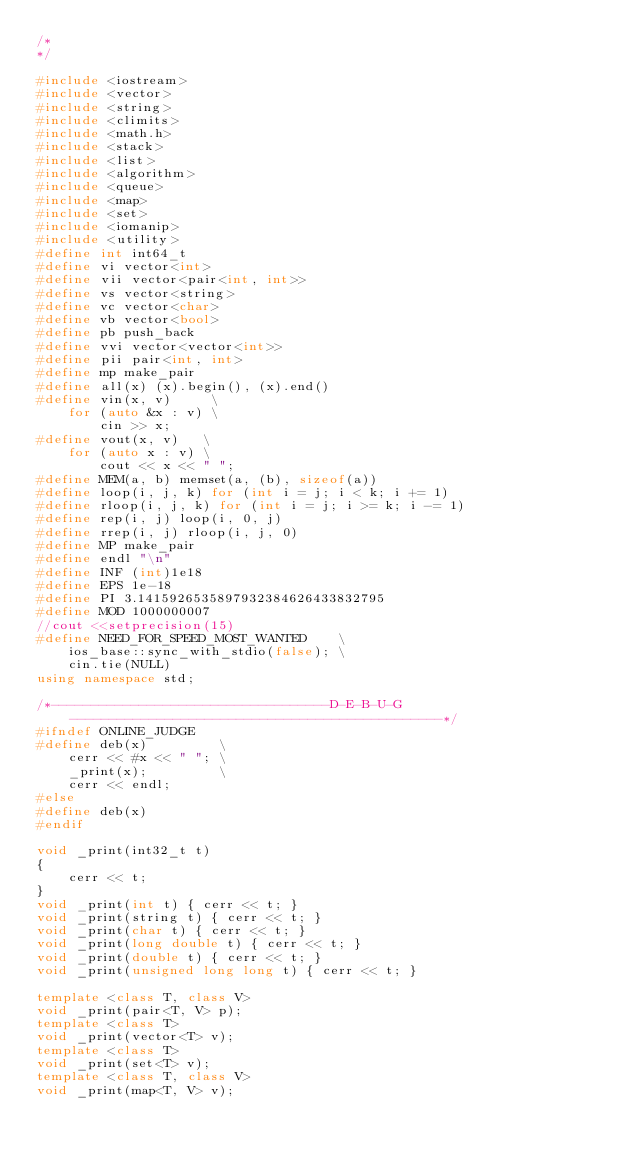Convert code to text. <code><loc_0><loc_0><loc_500><loc_500><_C++_>/*  
*/

#include <iostream>
#include <vector>
#include <string>
#include <climits>
#include <math.h>
#include <stack>
#include <list>
#include <algorithm>
#include <queue>
#include <map>
#include <set>
#include <iomanip>
#include <utility>
#define int int64_t
#define vi vector<int>
#define vii vector<pair<int, int>>
#define vs vector<string>
#define vc vector<char>
#define vb vector<bool>
#define pb push_back
#define vvi vector<vector<int>>
#define pii pair<int, int>
#define mp make_pair
#define all(x) (x).begin(), (x).end()
#define vin(x, v)     \
    for (auto &x : v) \
        cin >> x;
#define vout(x, v)   \
    for (auto x : v) \
        cout << x << " ";
#define MEM(a, b) memset(a, (b), sizeof(a))
#define loop(i, j, k) for (int i = j; i < k; i += 1)
#define rloop(i, j, k) for (int i = j; i >= k; i -= 1)
#define rep(i, j) loop(i, 0, j)
#define rrep(i, j) rloop(i, j, 0)
#define MP make_pair
#define endl "\n"
#define INF (int)1e18
#define EPS 1e-18
#define PI 3.1415926535897932384626433832795
#define MOD 1000000007
//cout <<setprecision(15)
#define NEED_FOR_SPEED_MOST_WANTED    \
    ios_base::sync_with_stdio(false); \
    cin.tie(NULL)
using namespace std;

/*-----------------------------------D-E-B-U-G-----------------------------------------------*/
#ifndef ONLINE_JUDGE
#define deb(x)         \
    cerr << #x << " "; \
    _print(x);         \
    cerr << endl;
#else
#define deb(x)
#endif

void _print(int32_t t)
{
    cerr << t;
}
void _print(int t) { cerr << t; }
void _print(string t) { cerr << t; }
void _print(char t) { cerr << t; }
void _print(long double t) { cerr << t; }
void _print(double t) { cerr << t; }
void _print(unsigned long long t) { cerr << t; }

template <class T, class V>
void _print(pair<T, V> p);
template <class T>
void _print(vector<T> v);
template <class T>
void _print(set<T> v);
template <class T, class V>
void _print(map<T, V> v);</code> 